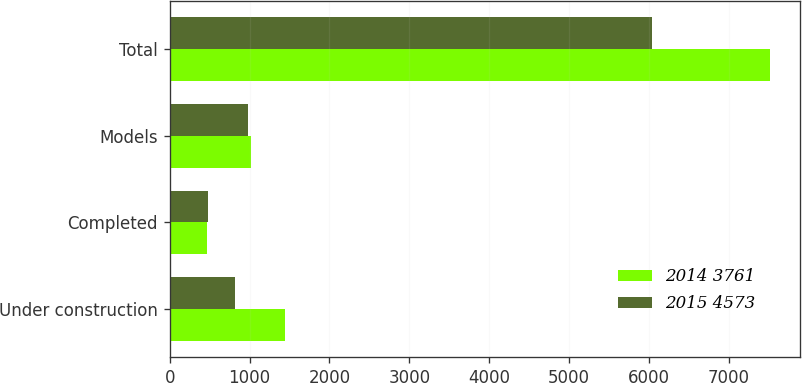Convert chart. <chart><loc_0><loc_0><loc_500><loc_500><stacked_bar_chart><ecel><fcel>Under construction<fcel>Completed<fcel>Models<fcel>Total<nl><fcel>2014 3761<fcel>1450<fcel>471<fcel>1024<fcel>7518<nl><fcel>2015 4573<fcel>815<fcel>483<fcel>981<fcel>6040<nl></chart> 